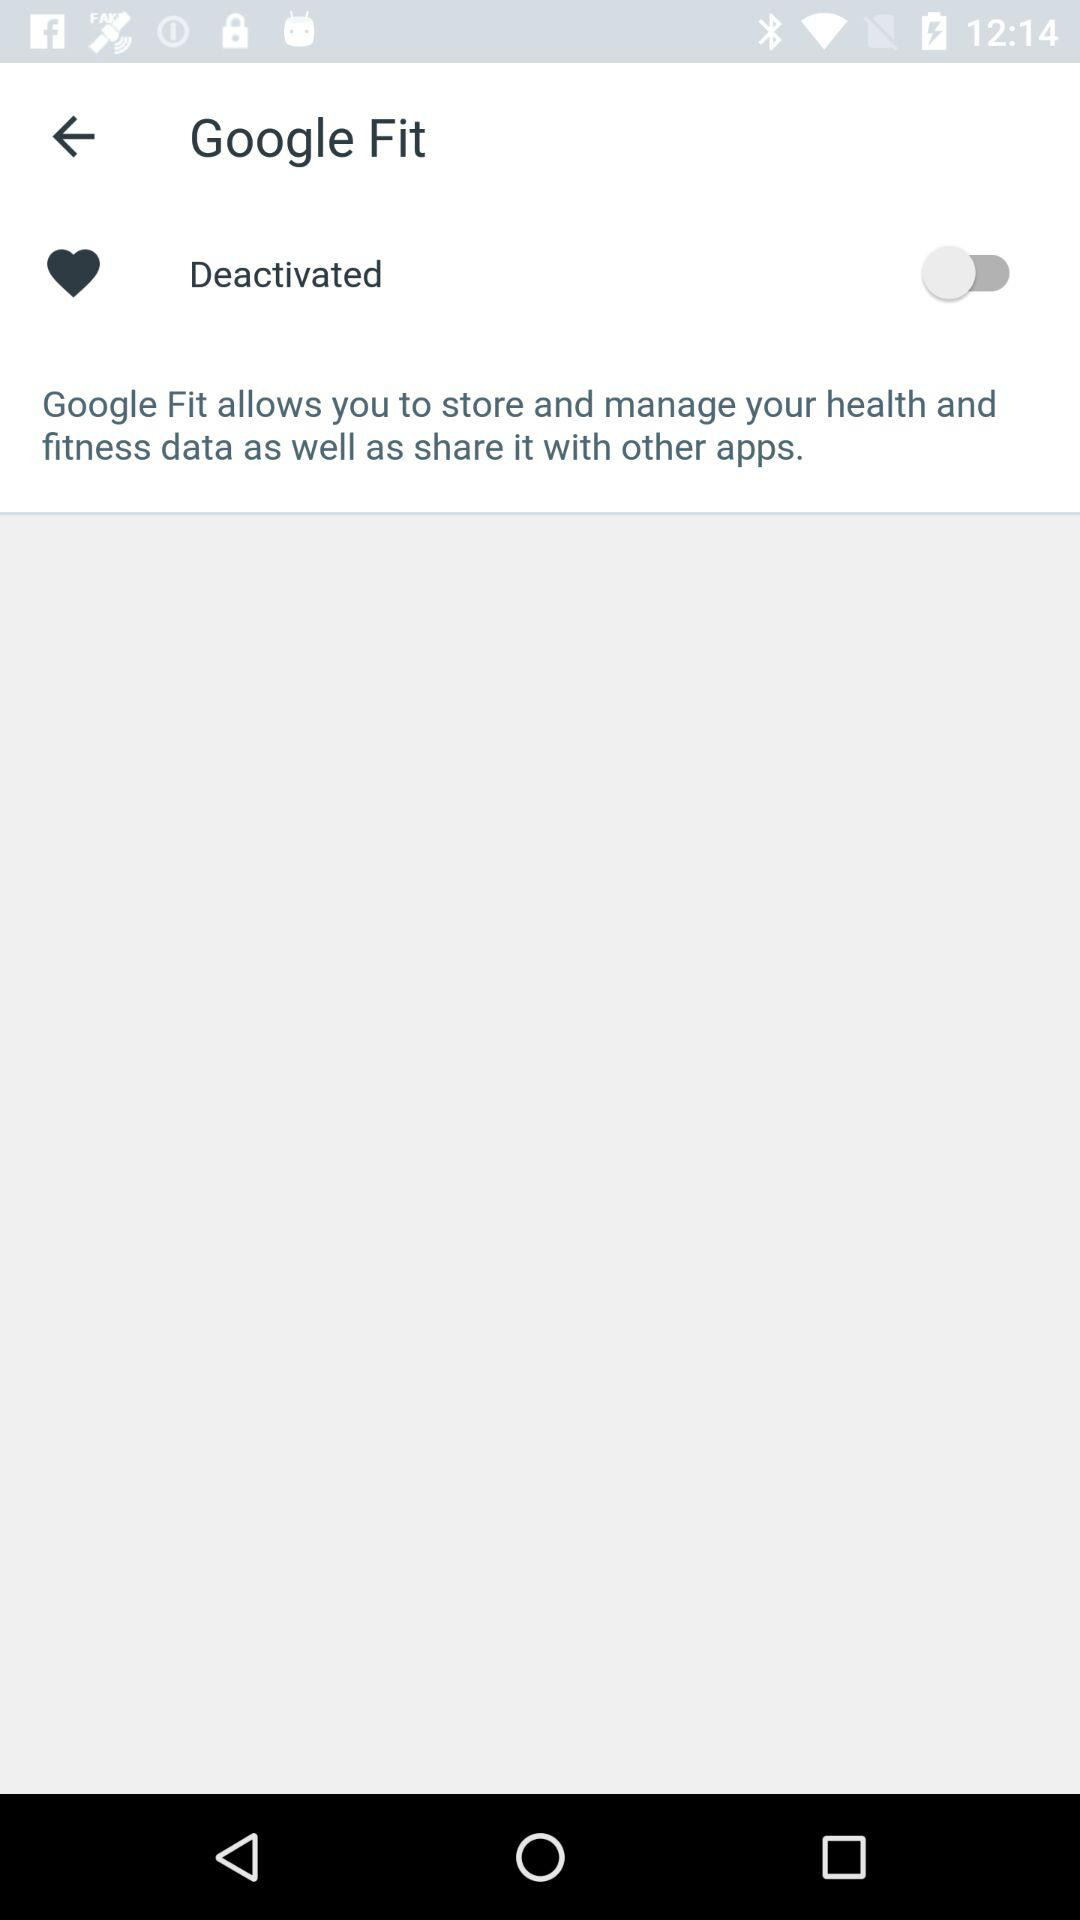What is the status of "Google Fit"? The status is "Deactivated". 